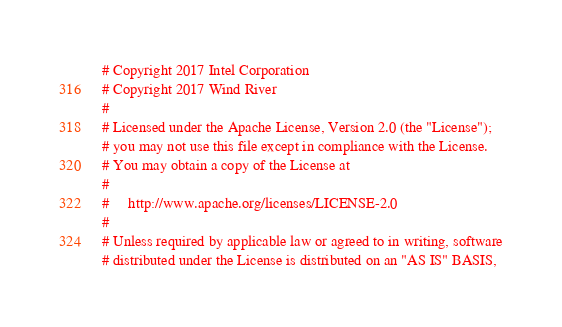Convert code to text. <code><loc_0><loc_0><loc_500><loc_500><_Python_># Copyright 2017 Intel Corporation
# Copyright 2017 Wind River
#
# Licensed under the Apache License, Version 2.0 (the "License");
# you may not use this file except in compliance with the License.
# You may obtain a copy of the License at
#
#     http://www.apache.org/licenses/LICENSE-2.0
#
# Unless required by applicable law or agreed to in writing, software
# distributed under the License is distributed on an "AS IS" BASIS,</code> 